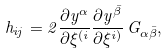Convert formula to latex. <formula><loc_0><loc_0><loc_500><loc_500>h _ { i j } = 2 \frac { \partial y ^ { \alpha } } { \partial \xi ^ { ( i } } \frac { \partial y ^ { \bar { \beta } } } { \partial \xi ^ { i ) } } \, G _ { \alpha \bar { \beta } } ,</formula> 